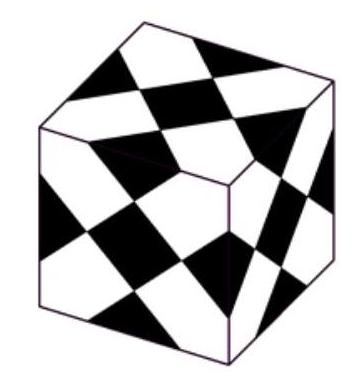Simon has a cube with side length $1 \mathrm{dm}$ made of glass. He sticks several equally big black squares on it, as shown on the right so that all faces look the same. How many $\mathrm{cm}^{2}$ were covered over?
 Answer is 225. 